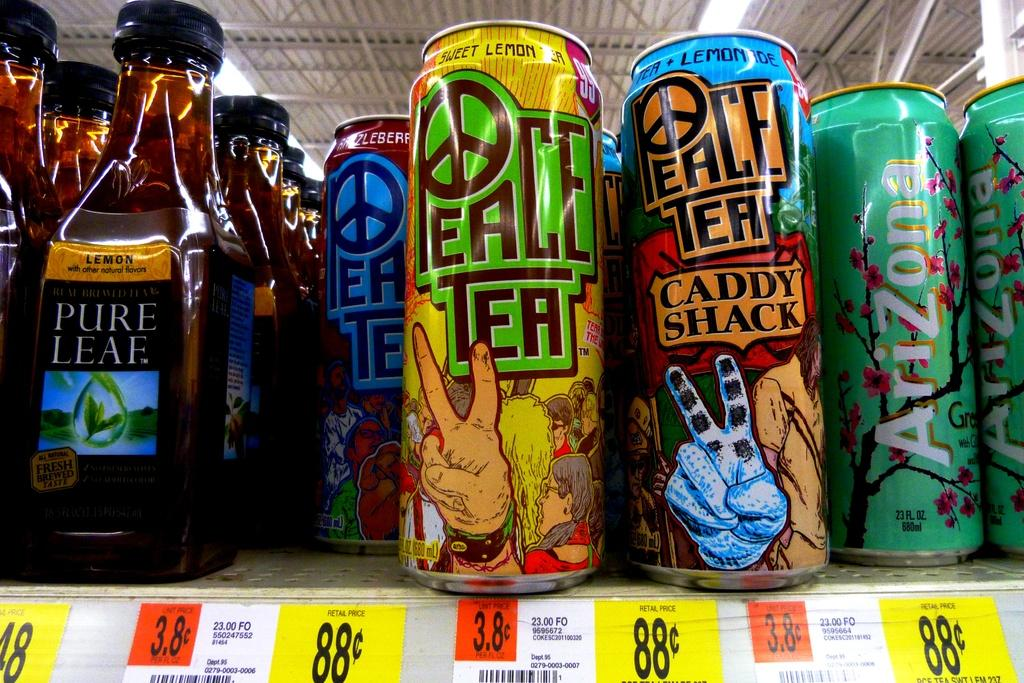<image>
Render a clear and concise summary of the photo. a store shelf that has cans that say 'peace' on them for 88 cents 